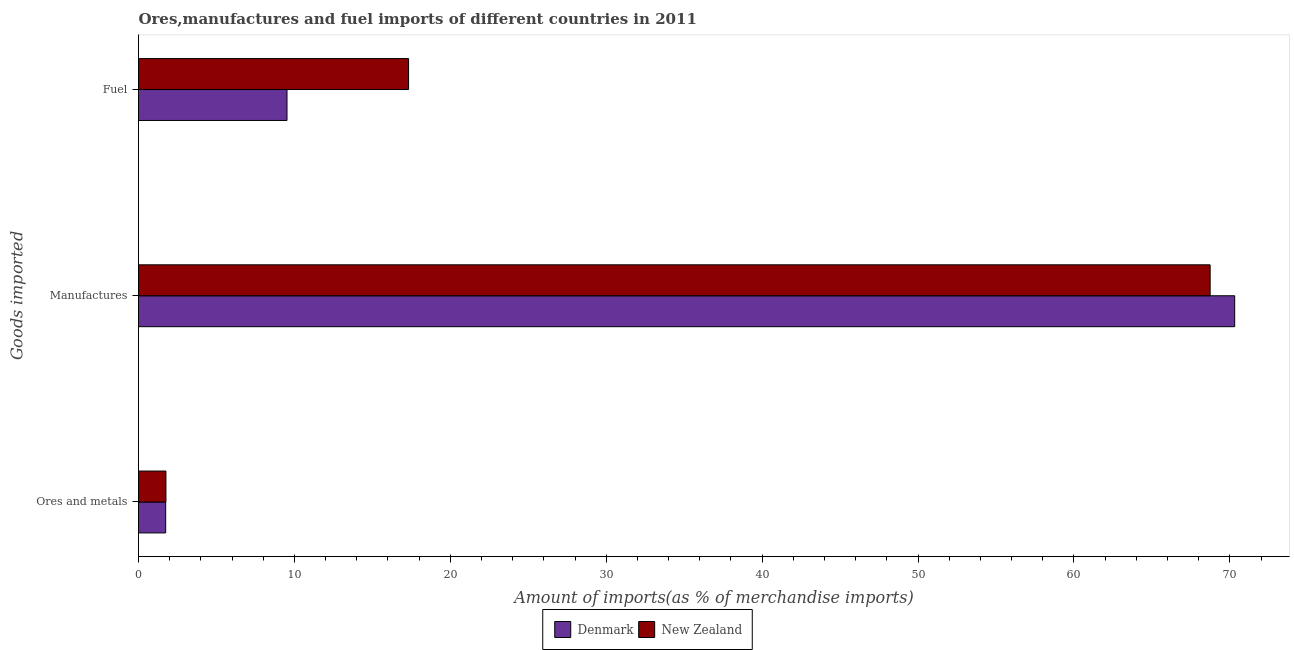How many different coloured bars are there?
Ensure brevity in your answer.  2. How many groups of bars are there?
Offer a very short reply. 3. Are the number of bars per tick equal to the number of legend labels?
Give a very brief answer. Yes. Are the number of bars on each tick of the Y-axis equal?
Your answer should be very brief. Yes. How many bars are there on the 1st tick from the top?
Keep it short and to the point. 2. What is the label of the 3rd group of bars from the top?
Make the answer very short. Ores and metals. What is the percentage of manufactures imports in New Zealand?
Provide a succinct answer. 68.74. Across all countries, what is the maximum percentage of fuel imports?
Ensure brevity in your answer.  17.32. Across all countries, what is the minimum percentage of fuel imports?
Give a very brief answer. 9.52. In which country was the percentage of ores and metals imports maximum?
Your response must be concise. New Zealand. In which country was the percentage of manufactures imports minimum?
Your response must be concise. New Zealand. What is the total percentage of manufactures imports in the graph?
Make the answer very short. 139.05. What is the difference between the percentage of manufactures imports in New Zealand and that in Denmark?
Your answer should be compact. -1.57. What is the difference between the percentage of ores and metals imports in New Zealand and the percentage of fuel imports in Denmark?
Your response must be concise. -7.76. What is the average percentage of ores and metals imports per country?
Ensure brevity in your answer.  1.75. What is the difference between the percentage of ores and metals imports and percentage of fuel imports in New Zealand?
Provide a succinct answer. -15.56. In how many countries, is the percentage of manufactures imports greater than 30 %?
Provide a short and direct response. 2. What is the ratio of the percentage of ores and metals imports in Denmark to that in New Zealand?
Give a very brief answer. 0.99. Is the percentage of fuel imports in Denmark less than that in New Zealand?
Your answer should be compact. Yes. What is the difference between the highest and the second highest percentage of fuel imports?
Give a very brief answer. 7.8. What is the difference between the highest and the lowest percentage of ores and metals imports?
Provide a succinct answer. 0.02. In how many countries, is the percentage of fuel imports greater than the average percentage of fuel imports taken over all countries?
Provide a succinct answer. 1. Is the sum of the percentage of manufactures imports in New Zealand and Denmark greater than the maximum percentage of fuel imports across all countries?
Your response must be concise. Yes. What does the 2nd bar from the top in Manufactures represents?
Your answer should be compact. Denmark. How many bars are there?
Provide a short and direct response. 6. What is the difference between two consecutive major ticks on the X-axis?
Offer a very short reply. 10. Are the values on the major ticks of X-axis written in scientific E-notation?
Provide a short and direct response. No. Does the graph contain any zero values?
Keep it short and to the point. No. Does the graph contain grids?
Ensure brevity in your answer.  No. How are the legend labels stacked?
Provide a succinct answer. Horizontal. What is the title of the graph?
Provide a short and direct response. Ores,manufactures and fuel imports of different countries in 2011. Does "High income: nonOECD" appear as one of the legend labels in the graph?
Provide a succinct answer. No. What is the label or title of the X-axis?
Make the answer very short. Amount of imports(as % of merchandise imports). What is the label or title of the Y-axis?
Give a very brief answer. Goods imported. What is the Amount of imports(as % of merchandise imports) in Denmark in Ores and metals?
Offer a terse response. 1.74. What is the Amount of imports(as % of merchandise imports) in New Zealand in Ores and metals?
Ensure brevity in your answer.  1.76. What is the Amount of imports(as % of merchandise imports) of Denmark in Manufactures?
Give a very brief answer. 70.31. What is the Amount of imports(as % of merchandise imports) in New Zealand in Manufactures?
Ensure brevity in your answer.  68.74. What is the Amount of imports(as % of merchandise imports) of Denmark in Fuel?
Provide a short and direct response. 9.52. What is the Amount of imports(as % of merchandise imports) in New Zealand in Fuel?
Keep it short and to the point. 17.32. Across all Goods imported, what is the maximum Amount of imports(as % of merchandise imports) in Denmark?
Give a very brief answer. 70.31. Across all Goods imported, what is the maximum Amount of imports(as % of merchandise imports) of New Zealand?
Offer a very short reply. 68.74. Across all Goods imported, what is the minimum Amount of imports(as % of merchandise imports) of Denmark?
Keep it short and to the point. 1.74. Across all Goods imported, what is the minimum Amount of imports(as % of merchandise imports) in New Zealand?
Keep it short and to the point. 1.76. What is the total Amount of imports(as % of merchandise imports) of Denmark in the graph?
Your response must be concise. 81.58. What is the total Amount of imports(as % of merchandise imports) in New Zealand in the graph?
Provide a short and direct response. 87.82. What is the difference between the Amount of imports(as % of merchandise imports) of Denmark in Ores and metals and that in Manufactures?
Your answer should be very brief. -68.57. What is the difference between the Amount of imports(as % of merchandise imports) in New Zealand in Ores and metals and that in Manufactures?
Make the answer very short. -66.98. What is the difference between the Amount of imports(as % of merchandise imports) of Denmark in Ores and metals and that in Fuel?
Your answer should be compact. -7.78. What is the difference between the Amount of imports(as % of merchandise imports) in New Zealand in Ores and metals and that in Fuel?
Provide a short and direct response. -15.56. What is the difference between the Amount of imports(as % of merchandise imports) in Denmark in Manufactures and that in Fuel?
Your response must be concise. 60.79. What is the difference between the Amount of imports(as % of merchandise imports) of New Zealand in Manufactures and that in Fuel?
Offer a very short reply. 51.41. What is the difference between the Amount of imports(as % of merchandise imports) in Denmark in Ores and metals and the Amount of imports(as % of merchandise imports) in New Zealand in Manufactures?
Offer a terse response. -66.99. What is the difference between the Amount of imports(as % of merchandise imports) of Denmark in Ores and metals and the Amount of imports(as % of merchandise imports) of New Zealand in Fuel?
Your response must be concise. -15.58. What is the difference between the Amount of imports(as % of merchandise imports) in Denmark in Manufactures and the Amount of imports(as % of merchandise imports) in New Zealand in Fuel?
Give a very brief answer. 52.99. What is the average Amount of imports(as % of merchandise imports) of Denmark per Goods imported?
Your answer should be compact. 27.19. What is the average Amount of imports(as % of merchandise imports) in New Zealand per Goods imported?
Offer a terse response. 29.27. What is the difference between the Amount of imports(as % of merchandise imports) in Denmark and Amount of imports(as % of merchandise imports) in New Zealand in Ores and metals?
Make the answer very short. -0.02. What is the difference between the Amount of imports(as % of merchandise imports) in Denmark and Amount of imports(as % of merchandise imports) in New Zealand in Manufactures?
Your answer should be compact. 1.57. What is the difference between the Amount of imports(as % of merchandise imports) in Denmark and Amount of imports(as % of merchandise imports) in New Zealand in Fuel?
Provide a succinct answer. -7.8. What is the ratio of the Amount of imports(as % of merchandise imports) of Denmark in Ores and metals to that in Manufactures?
Your response must be concise. 0.02. What is the ratio of the Amount of imports(as % of merchandise imports) in New Zealand in Ores and metals to that in Manufactures?
Provide a short and direct response. 0.03. What is the ratio of the Amount of imports(as % of merchandise imports) in Denmark in Ores and metals to that in Fuel?
Your answer should be very brief. 0.18. What is the ratio of the Amount of imports(as % of merchandise imports) in New Zealand in Ores and metals to that in Fuel?
Your answer should be very brief. 0.1. What is the ratio of the Amount of imports(as % of merchandise imports) of Denmark in Manufactures to that in Fuel?
Your answer should be very brief. 7.38. What is the ratio of the Amount of imports(as % of merchandise imports) of New Zealand in Manufactures to that in Fuel?
Provide a short and direct response. 3.97. What is the difference between the highest and the second highest Amount of imports(as % of merchandise imports) in Denmark?
Offer a very short reply. 60.79. What is the difference between the highest and the second highest Amount of imports(as % of merchandise imports) of New Zealand?
Provide a short and direct response. 51.41. What is the difference between the highest and the lowest Amount of imports(as % of merchandise imports) in Denmark?
Give a very brief answer. 68.57. What is the difference between the highest and the lowest Amount of imports(as % of merchandise imports) in New Zealand?
Keep it short and to the point. 66.98. 